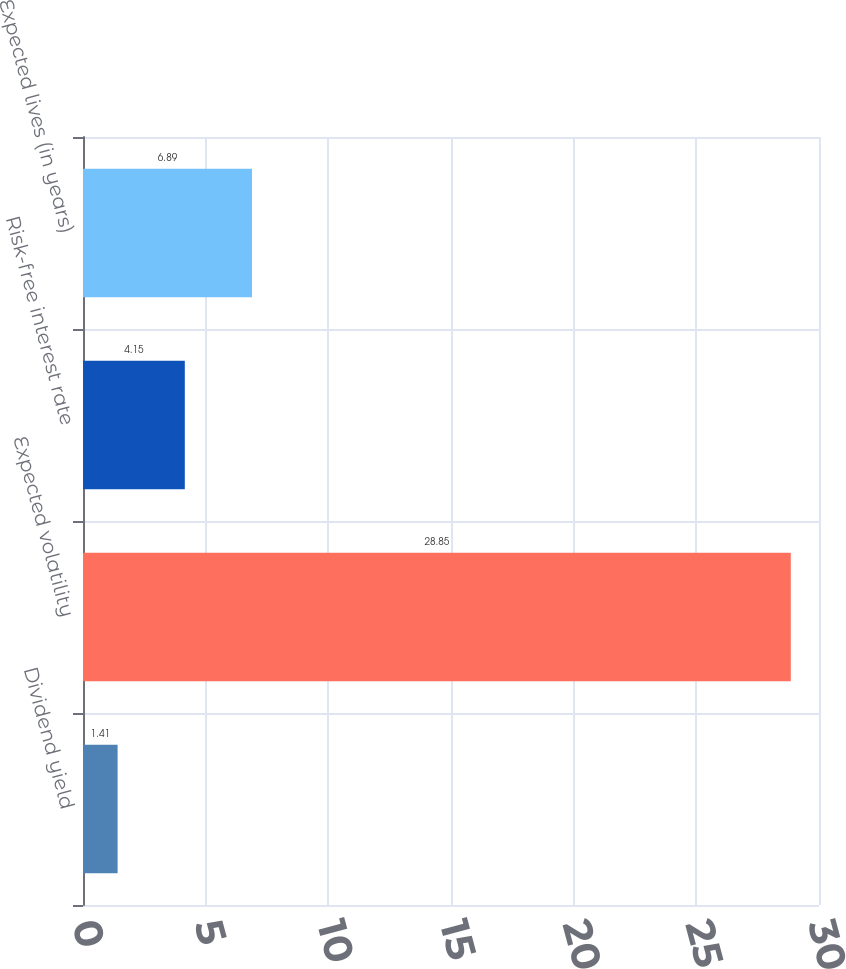Convert chart to OTSL. <chart><loc_0><loc_0><loc_500><loc_500><bar_chart><fcel>Dividend yield<fcel>Expected volatility<fcel>Risk-free interest rate<fcel>Expected lives (in years)<nl><fcel>1.41<fcel>28.85<fcel>4.15<fcel>6.89<nl></chart> 